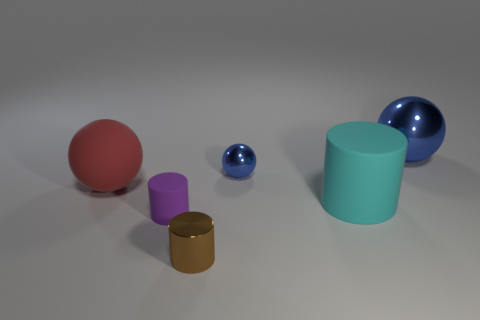Does the big cyan object have the same shape as the large blue object?
Offer a terse response. No. What number of matte objects are either big objects or tiny purple cylinders?
Your response must be concise. 3. There is a thing that is the same color as the small metallic ball; what material is it?
Give a very brief answer. Metal. Do the red thing and the brown shiny object have the same size?
Your answer should be compact. No. How many objects are either brown metallic cylinders or large balls right of the red rubber ball?
Keep it short and to the point. 2. What material is the sphere that is the same size as the red object?
Your response must be concise. Metal. What is the large object that is left of the big metal sphere and to the right of the small purple rubber cylinder made of?
Ensure brevity in your answer.  Rubber. Are there any large matte spheres that are on the right side of the large matte thing that is right of the large red matte ball?
Provide a short and direct response. No. There is a metal object that is behind the brown shiny thing and to the left of the cyan cylinder; what is its size?
Keep it short and to the point. Small. How many purple things are either large balls or large matte cylinders?
Ensure brevity in your answer.  0. 